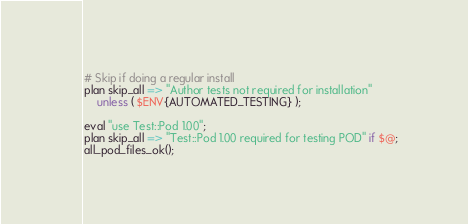<code> <loc_0><loc_0><loc_500><loc_500><_Perl_>
# Skip if doing a regular install
plan skip_all => "Author tests not required for installation"
    unless ( $ENV{AUTOMATED_TESTING} );

eval "use Test::Pod 1.00";
plan skip_all => "Test::Pod 1.00 required for testing POD" if $@;
all_pod_files_ok();
</code> 